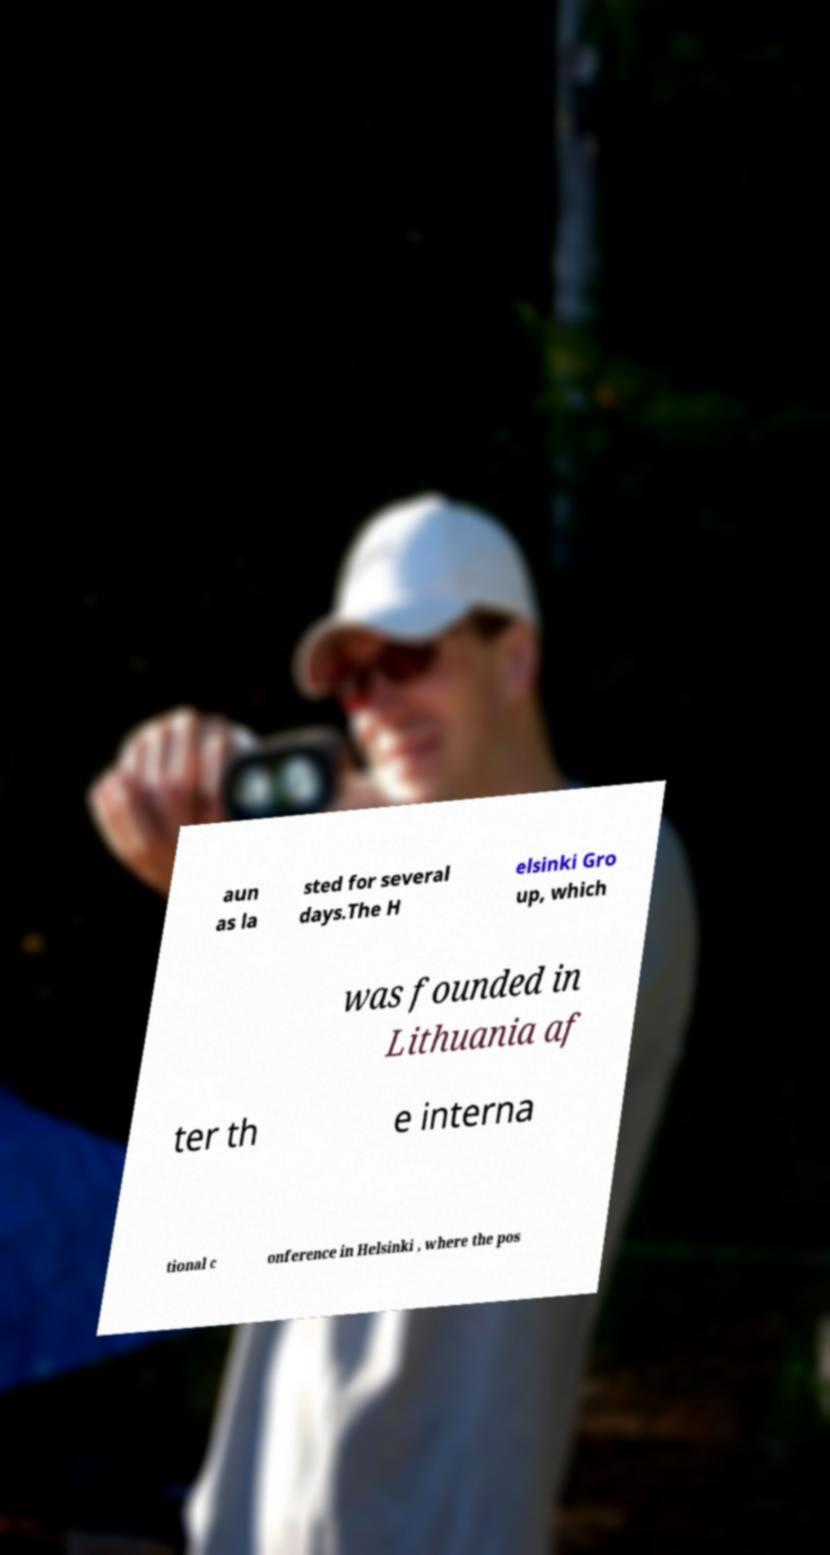Can you read and provide the text displayed in the image?This photo seems to have some interesting text. Can you extract and type it out for me? aun as la sted for several days.The H elsinki Gro up, which was founded in Lithuania af ter th e interna tional c onference in Helsinki , where the pos 